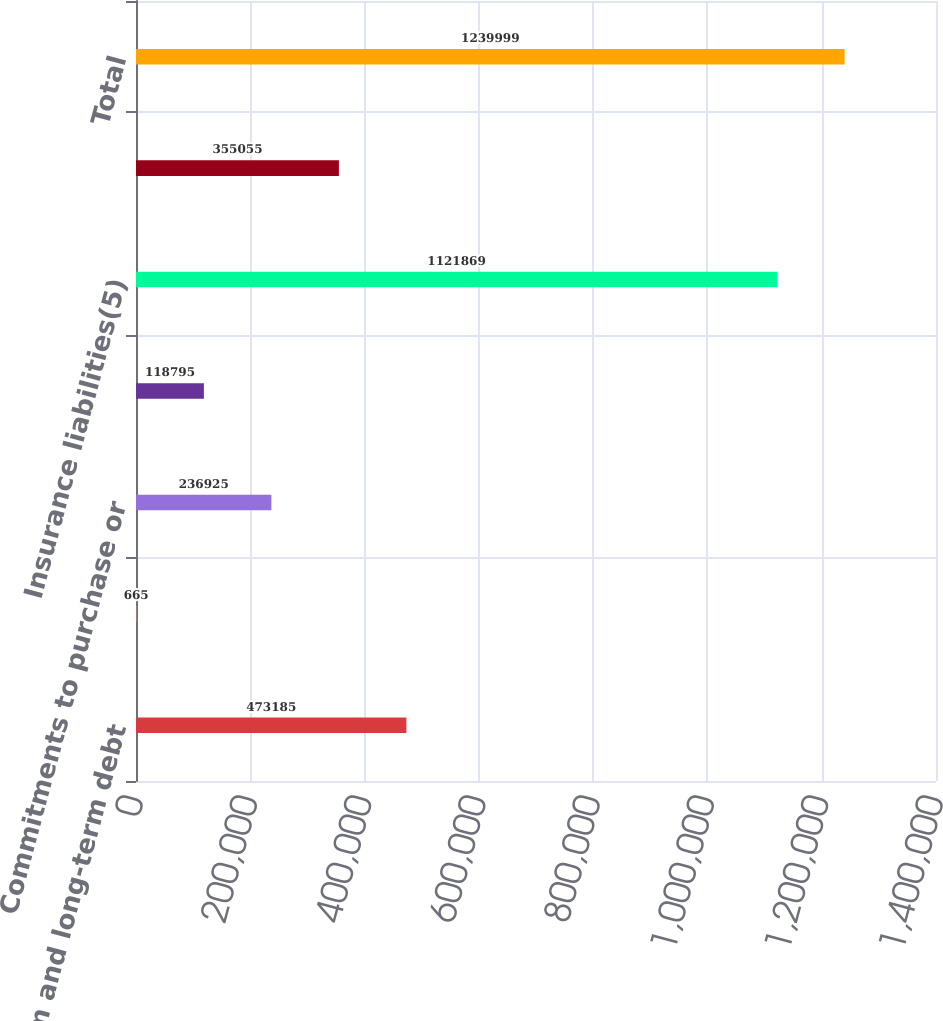<chart> <loc_0><loc_0><loc_500><loc_500><bar_chart><fcel>Short-term and long-term debt<fcel>Operating and capital lease<fcel>Commitments to purchase or<fcel>Commercial mortgage loan<fcel>Insurance liabilities(5)<fcel>Other(6)<fcel>Total<nl><fcel>473185<fcel>665<fcel>236925<fcel>118795<fcel>1.12187e+06<fcel>355055<fcel>1.24e+06<nl></chart> 